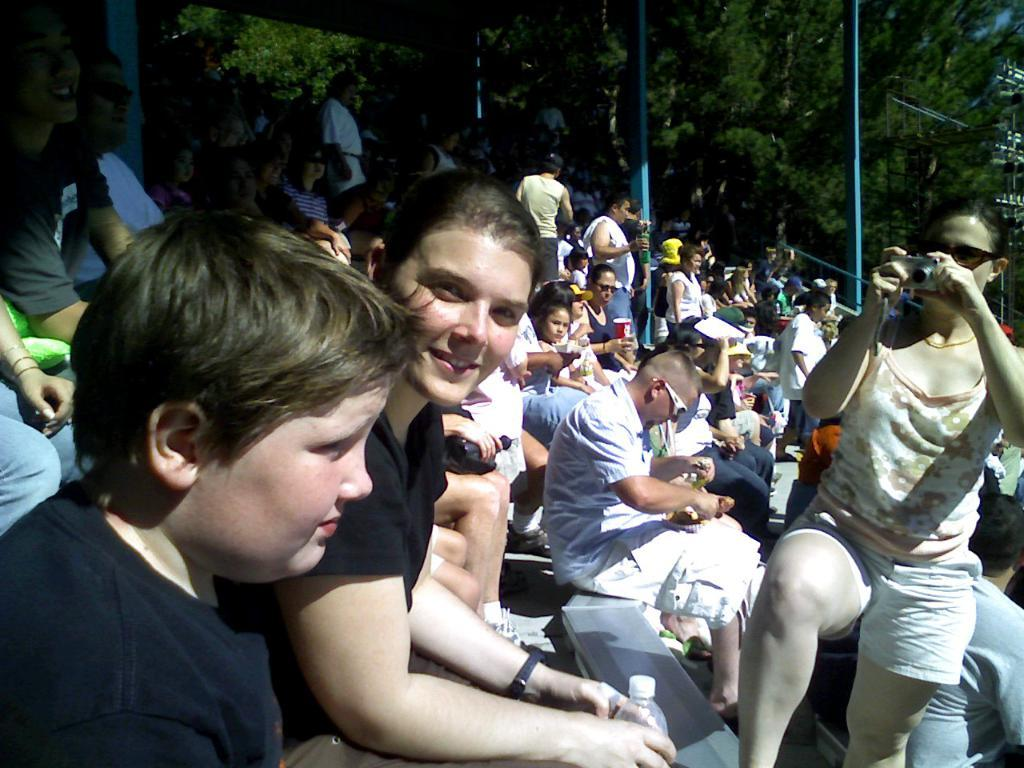What is happening in the image involving a group of people? There is a group of people in the image, and some of them are holding bottles, cups, and a camera. What objects are being held by the people in the image? Some people are holding bottles, cups, and a camera. What can be seen in the background of the image? There are poles and trees visible in the background. What type of dog can be seen interacting with the people holding a camera in the image? There is no dog present in the image; it only features a group of people holding various objects. How much knowledge can be gained from the dime visible in the image? There is no dime present in the image, so no knowledge can be gained from it. 